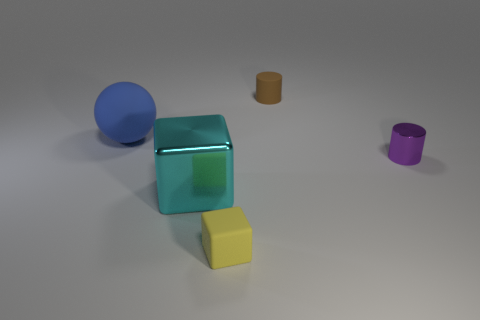Add 4 yellow blocks. How many objects exist? 9 Subtract all cylinders. How many objects are left? 3 Subtract all large metal cubes. Subtract all brown cylinders. How many objects are left? 3 Add 4 blue rubber objects. How many blue rubber objects are left? 5 Add 1 tiny metal cylinders. How many tiny metal cylinders exist? 2 Subtract 0 red cubes. How many objects are left? 5 